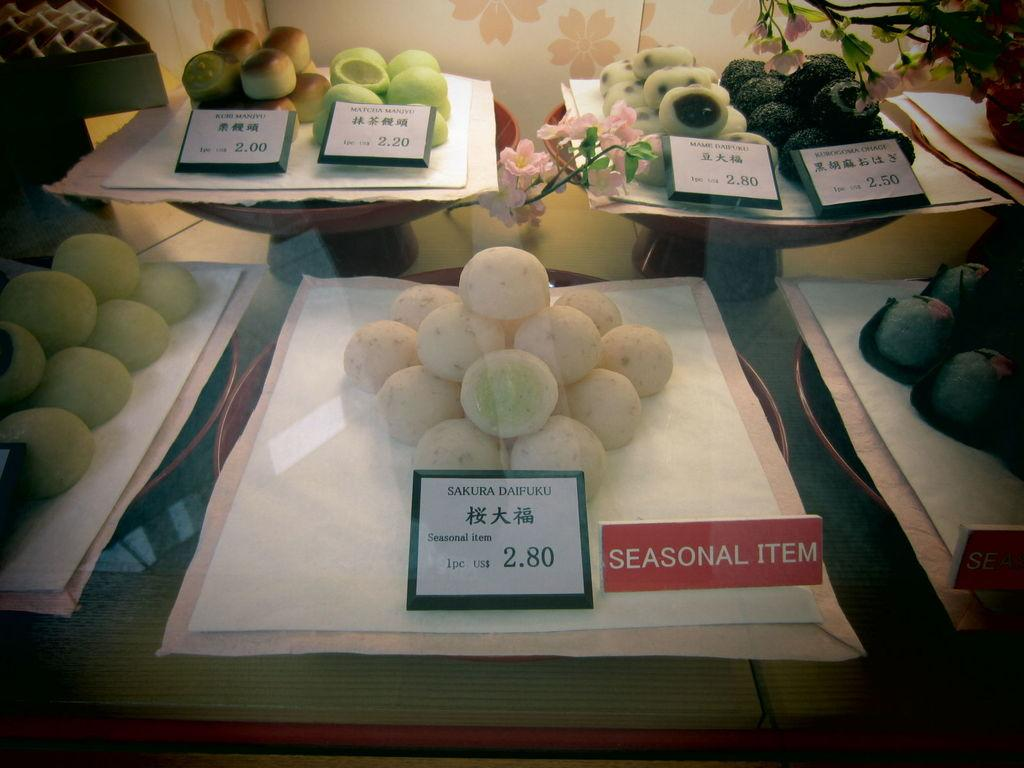What can be seen in the image related to food? There are different kinds of food items in the image. How are the food items presented? The food items are on a paper. What information is provided along with the food items? There are price boards on the paper. What else can be seen in the image besides the food items and price boards? There are other things visible behind the food items. Can you tell me which guide is being used to prepare the food in the image? There is no guide visible in the image; it only shows food items and price boards on a paper. Is there any ice visible in the image? There is no ice present in the image. 